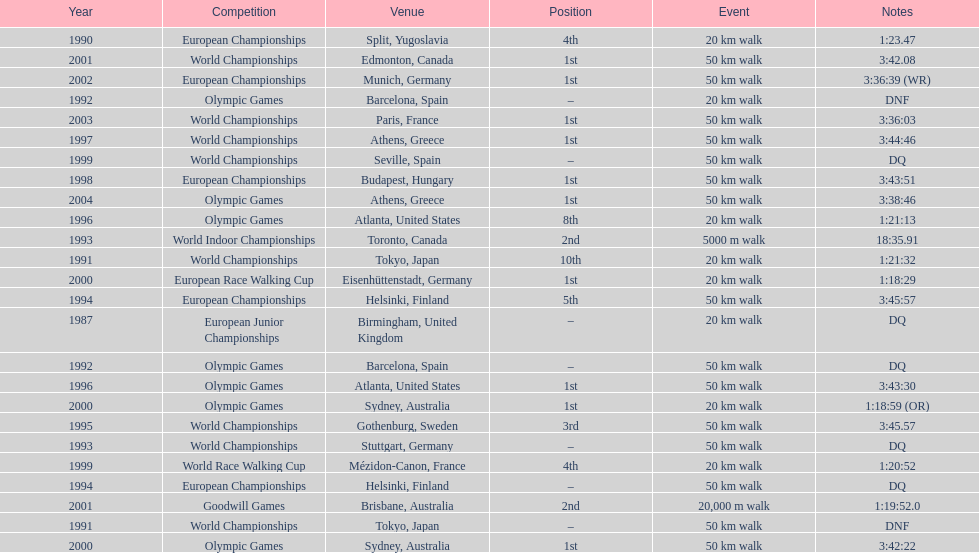In what year was korzeniowski's last competition? 2004. 